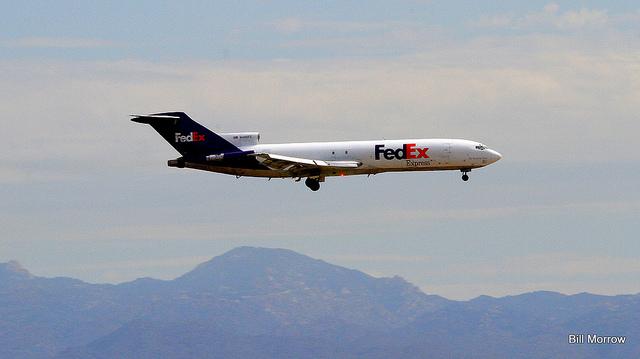What company owns this plane?
Be succinct. Fedex. Is this plane ascending or descending?
Be succinct. Descending. Are the wheels put away?
Be succinct. No. 